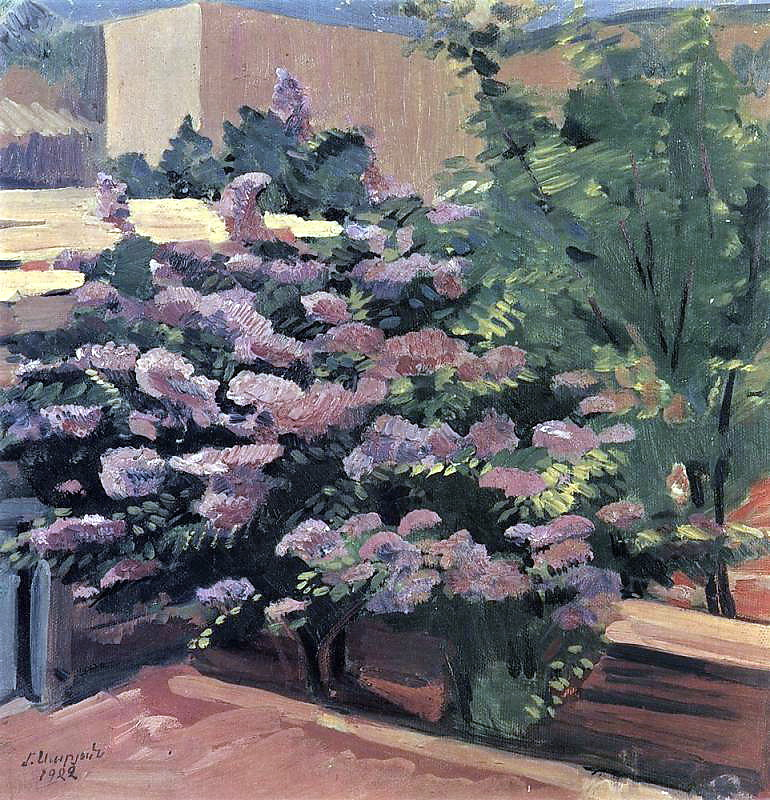Based on this garden, create a short poem. In a garden where dreams take flight,
Blossoms kiss the morning light.
Petals whisper tales untold,
In hues of pink, purple, and gold.
Amidst the green, where shadows play,
Nature weaves both night and day.
Here in hush, the world so still,
Time pauses at the garden's will. 